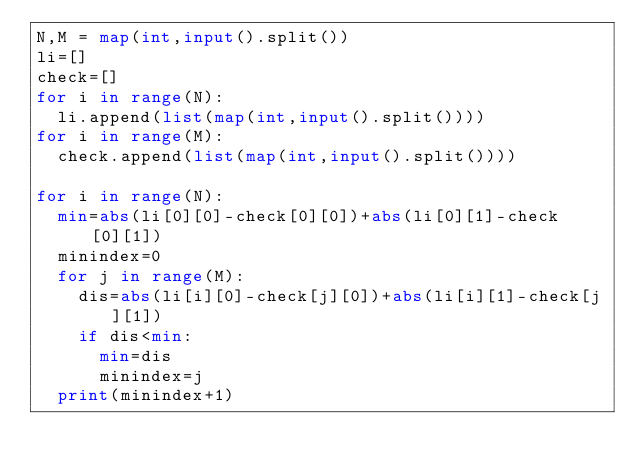<code> <loc_0><loc_0><loc_500><loc_500><_Python_>N,M = map(int,input().split())
li=[]
check=[]
for i in range(N):
  li.append(list(map(int,input().split())))
for i in range(M):
  check.append(list(map(int,input().split())))

for i in range(N):
  min=abs(li[0][0]-check[0][0])+abs(li[0][1]-check[0][1])
  minindex=0
  for j in range(M):
    dis=abs(li[i][0]-check[j][0])+abs(li[i][1]-check[j][1])
    if dis<min:
      min=dis
      minindex=j
  print(minindex+1)</code> 